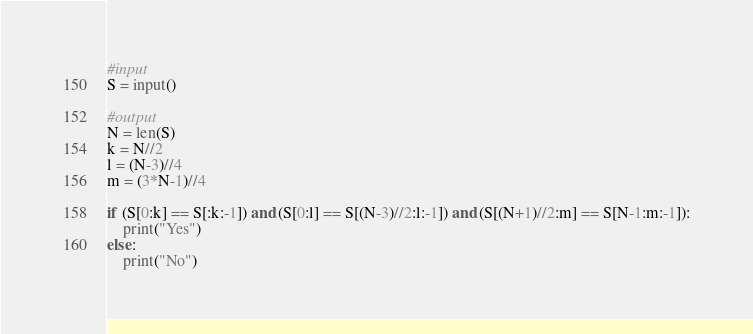Convert code to text. <code><loc_0><loc_0><loc_500><loc_500><_Python_>#input
S = input()

#output
N = len(S)
k = N//2
l = (N-3)//4
m = (3*N-1)//4

if (S[0:k] == S[:k:-1]) and (S[0:l] == S[(N-3)//2:l:-1]) and (S[(N+1)//2:m] == S[N-1:m:-1]):
    print("Yes")
else:
    print("No")</code> 